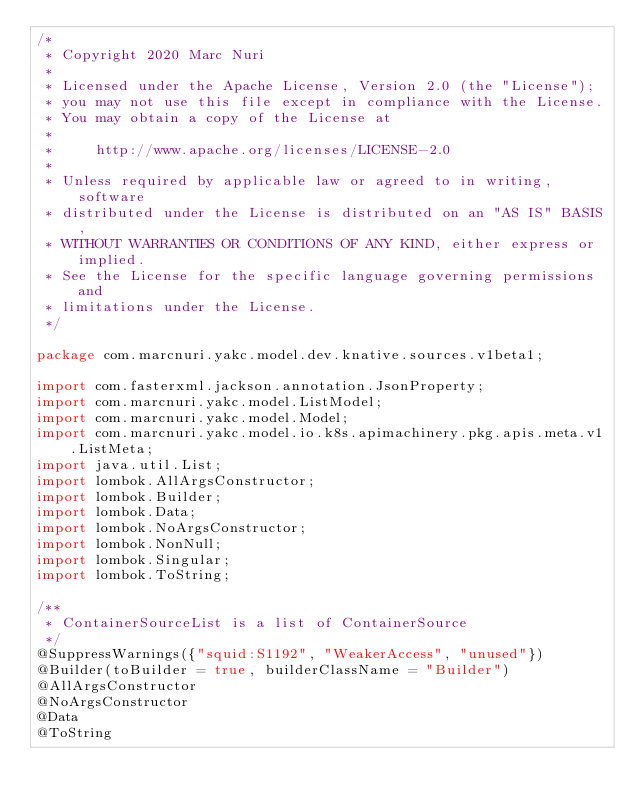Convert code to text. <code><loc_0><loc_0><loc_500><loc_500><_Java_>/*
 * Copyright 2020 Marc Nuri
 *
 * Licensed under the Apache License, Version 2.0 (the "License");
 * you may not use this file except in compliance with the License.
 * You may obtain a copy of the License at
 *
 *     http://www.apache.org/licenses/LICENSE-2.0
 *
 * Unless required by applicable law or agreed to in writing, software
 * distributed under the License is distributed on an "AS IS" BASIS,
 * WITHOUT WARRANTIES OR CONDITIONS OF ANY KIND, either express or implied.
 * See the License for the specific language governing permissions and
 * limitations under the License.
 */

package com.marcnuri.yakc.model.dev.knative.sources.v1beta1;

import com.fasterxml.jackson.annotation.JsonProperty;
import com.marcnuri.yakc.model.ListModel;
import com.marcnuri.yakc.model.Model;
import com.marcnuri.yakc.model.io.k8s.apimachinery.pkg.apis.meta.v1.ListMeta;
import java.util.List;
import lombok.AllArgsConstructor;
import lombok.Builder;
import lombok.Data;
import lombok.NoArgsConstructor;
import lombok.NonNull;
import lombok.Singular;
import lombok.ToString;

/**
 * ContainerSourceList is a list of ContainerSource
 */
@SuppressWarnings({"squid:S1192", "WeakerAccess", "unused"})
@Builder(toBuilder = true, builderClassName = "Builder")
@AllArgsConstructor
@NoArgsConstructor
@Data
@ToString</code> 